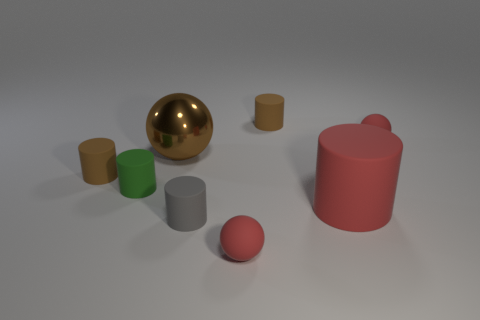Subtract all green rubber cylinders. How many cylinders are left? 4 Subtract all red cylinders. How many red balls are left? 2 Subtract 1 cylinders. How many cylinders are left? 4 Subtract all green cylinders. How many cylinders are left? 4 Add 2 small red objects. How many objects exist? 10 Subtract all cylinders. How many objects are left? 3 Subtract all cyan balls. Subtract all red cubes. How many balls are left? 3 Add 5 big red matte things. How many big red matte things are left? 6 Add 8 large gray rubber things. How many large gray rubber things exist? 8 Subtract 1 brown cylinders. How many objects are left? 7 